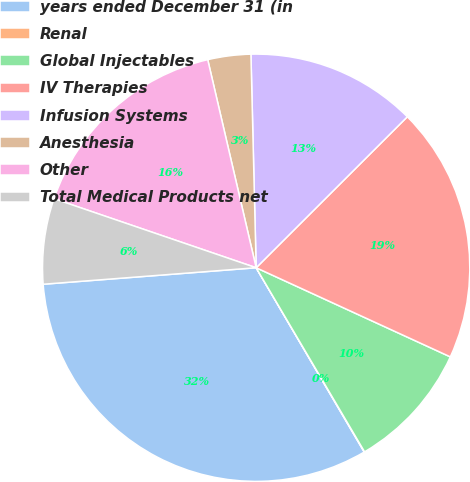Convert chart. <chart><loc_0><loc_0><loc_500><loc_500><pie_chart><fcel>years ended December 31 (in<fcel>Renal<fcel>Global Injectables<fcel>IV Therapies<fcel>Infusion Systems<fcel>Anesthesia<fcel>Other<fcel>Total Medical Products net<nl><fcel>32.21%<fcel>0.03%<fcel>9.68%<fcel>19.34%<fcel>12.9%<fcel>3.25%<fcel>16.12%<fcel>6.47%<nl></chart> 